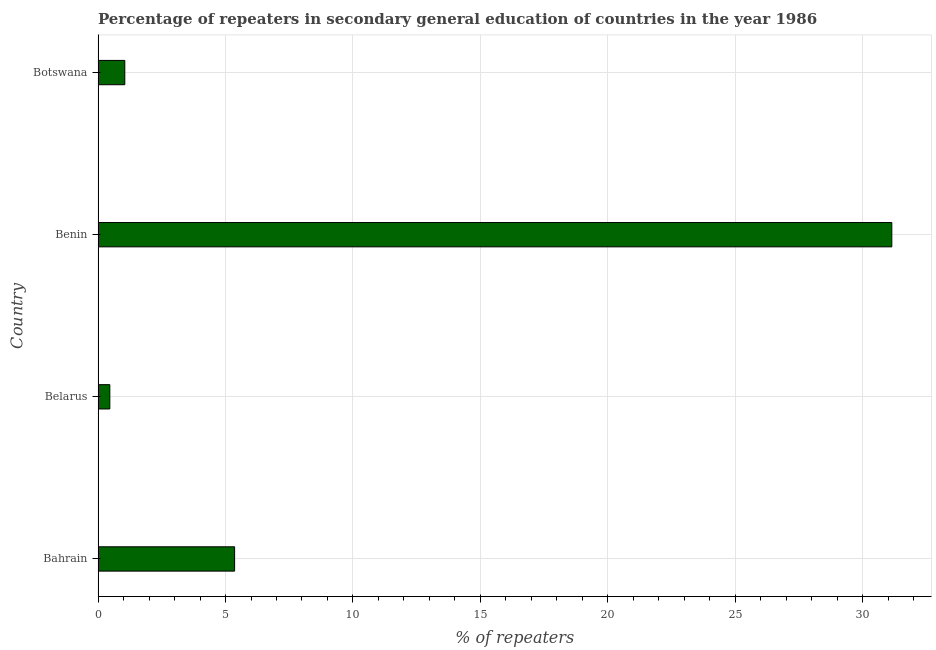Does the graph contain grids?
Provide a succinct answer. Yes. What is the title of the graph?
Provide a short and direct response. Percentage of repeaters in secondary general education of countries in the year 1986. What is the label or title of the X-axis?
Make the answer very short. % of repeaters. What is the label or title of the Y-axis?
Your response must be concise. Country. What is the percentage of repeaters in Belarus?
Keep it short and to the point. 0.46. Across all countries, what is the maximum percentage of repeaters?
Provide a short and direct response. 31.14. Across all countries, what is the minimum percentage of repeaters?
Provide a succinct answer. 0.46. In which country was the percentage of repeaters maximum?
Make the answer very short. Benin. In which country was the percentage of repeaters minimum?
Provide a short and direct response. Belarus. What is the sum of the percentage of repeaters?
Give a very brief answer. 38.01. What is the difference between the percentage of repeaters in Benin and Botswana?
Your response must be concise. 30.1. What is the average percentage of repeaters per country?
Ensure brevity in your answer.  9.5. What is the median percentage of repeaters?
Give a very brief answer. 3.2. What is the ratio of the percentage of repeaters in Bahrain to that in Benin?
Your response must be concise. 0.17. Is the percentage of repeaters in Bahrain less than that in Botswana?
Your answer should be very brief. No. Is the difference between the percentage of repeaters in Belarus and Benin greater than the difference between any two countries?
Ensure brevity in your answer.  Yes. What is the difference between the highest and the second highest percentage of repeaters?
Keep it short and to the point. 25.79. Is the sum of the percentage of repeaters in Benin and Botswana greater than the maximum percentage of repeaters across all countries?
Your answer should be compact. Yes. What is the difference between the highest and the lowest percentage of repeaters?
Provide a short and direct response. 30.68. In how many countries, is the percentage of repeaters greater than the average percentage of repeaters taken over all countries?
Your answer should be compact. 1. Are all the bars in the graph horizontal?
Provide a succinct answer. Yes. What is the % of repeaters of Bahrain?
Offer a very short reply. 5.36. What is the % of repeaters of Belarus?
Keep it short and to the point. 0.46. What is the % of repeaters of Benin?
Provide a succinct answer. 31.14. What is the % of repeaters in Botswana?
Your response must be concise. 1.05. What is the difference between the % of repeaters in Bahrain and Belarus?
Make the answer very short. 4.9. What is the difference between the % of repeaters in Bahrain and Benin?
Provide a succinct answer. -25.79. What is the difference between the % of repeaters in Bahrain and Botswana?
Offer a terse response. 4.31. What is the difference between the % of repeaters in Belarus and Benin?
Ensure brevity in your answer.  -30.68. What is the difference between the % of repeaters in Belarus and Botswana?
Give a very brief answer. -0.59. What is the difference between the % of repeaters in Benin and Botswana?
Your answer should be compact. 30.1. What is the ratio of the % of repeaters in Bahrain to that in Belarus?
Keep it short and to the point. 11.63. What is the ratio of the % of repeaters in Bahrain to that in Benin?
Offer a very short reply. 0.17. What is the ratio of the % of repeaters in Bahrain to that in Botswana?
Your response must be concise. 5.11. What is the ratio of the % of repeaters in Belarus to that in Benin?
Offer a terse response. 0.01. What is the ratio of the % of repeaters in Belarus to that in Botswana?
Ensure brevity in your answer.  0.44. What is the ratio of the % of repeaters in Benin to that in Botswana?
Ensure brevity in your answer.  29.71. 